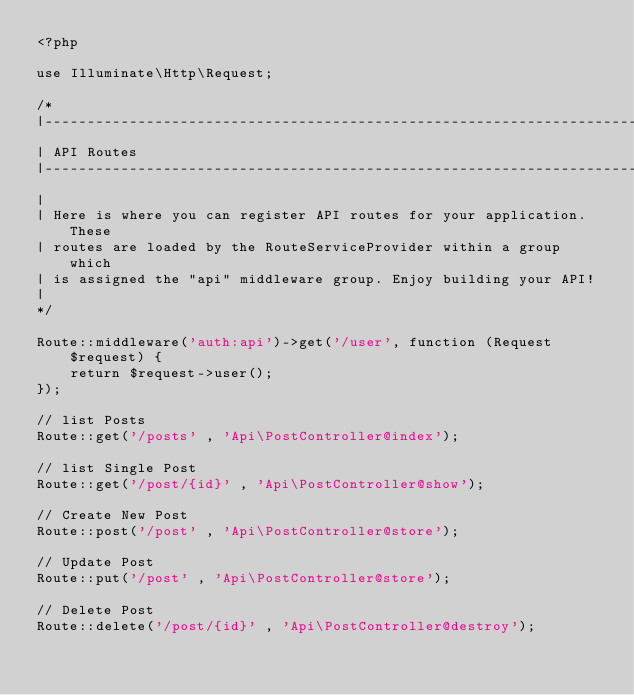Convert code to text. <code><loc_0><loc_0><loc_500><loc_500><_PHP_><?php

use Illuminate\Http\Request;

/*
|--------------------------------------------------------------------------
| API Routes
|--------------------------------------------------------------------------
|
| Here is where you can register API routes for your application. These
| routes are loaded by the RouteServiceProvider within a group which
| is assigned the "api" middleware group. Enjoy building your API!
|
*/

Route::middleware('auth:api')->get('/user', function (Request $request) {
    return $request->user();
});

// list Posts
Route::get('/posts' , 'Api\PostController@index');

// list Single Post
Route::get('/post/{id}' , 'Api\PostController@show');

// Create New Post
Route::post('/post' , 'Api\PostController@store');

// Update Post
Route::put('/post' , 'Api\PostController@store');

// Delete Post
Route::delete('/post/{id}' , 'Api\PostController@destroy');
</code> 